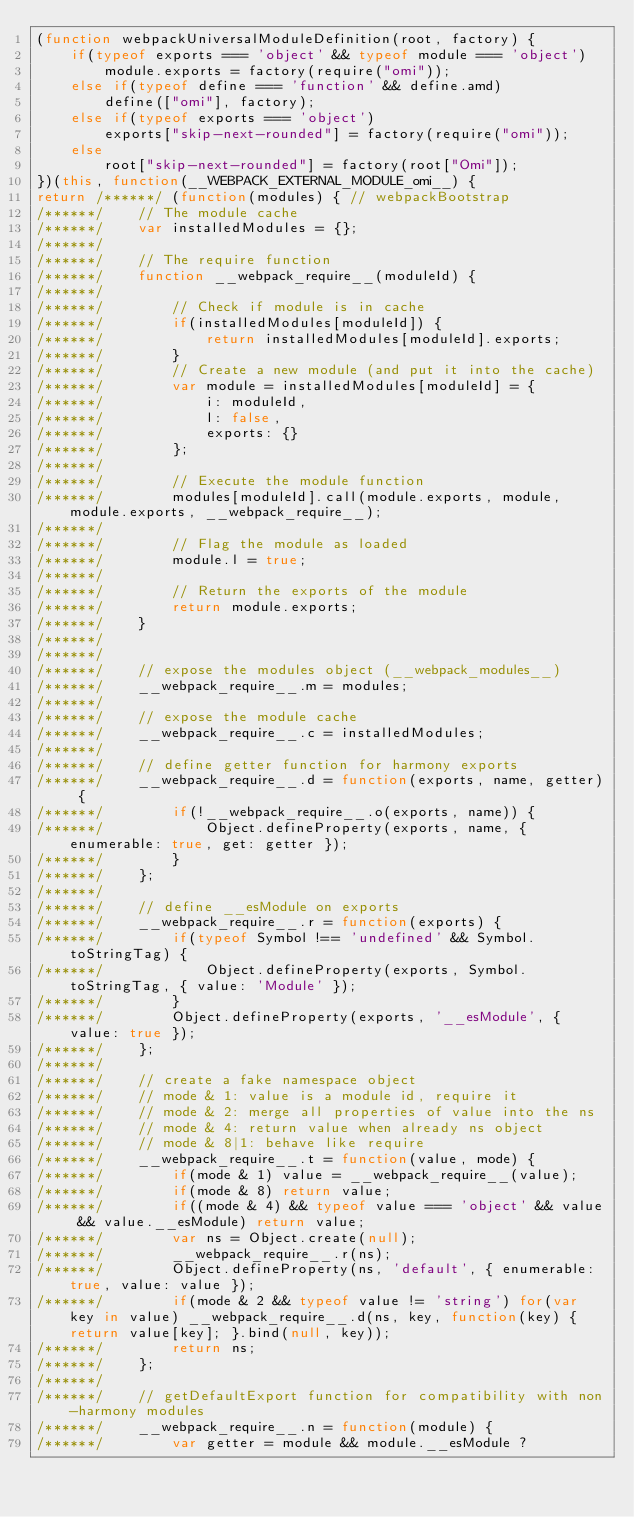<code> <loc_0><loc_0><loc_500><loc_500><_JavaScript_>(function webpackUniversalModuleDefinition(root, factory) {
	if(typeof exports === 'object' && typeof module === 'object')
		module.exports = factory(require("omi"));
	else if(typeof define === 'function' && define.amd)
		define(["omi"], factory);
	else if(typeof exports === 'object')
		exports["skip-next-rounded"] = factory(require("omi"));
	else
		root["skip-next-rounded"] = factory(root["Omi"]);
})(this, function(__WEBPACK_EXTERNAL_MODULE_omi__) {
return /******/ (function(modules) { // webpackBootstrap
/******/ 	// The module cache
/******/ 	var installedModules = {};
/******/
/******/ 	// The require function
/******/ 	function __webpack_require__(moduleId) {
/******/
/******/ 		// Check if module is in cache
/******/ 		if(installedModules[moduleId]) {
/******/ 			return installedModules[moduleId].exports;
/******/ 		}
/******/ 		// Create a new module (and put it into the cache)
/******/ 		var module = installedModules[moduleId] = {
/******/ 			i: moduleId,
/******/ 			l: false,
/******/ 			exports: {}
/******/ 		};
/******/
/******/ 		// Execute the module function
/******/ 		modules[moduleId].call(module.exports, module, module.exports, __webpack_require__);
/******/
/******/ 		// Flag the module as loaded
/******/ 		module.l = true;
/******/
/******/ 		// Return the exports of the module
/******/ 		return module.exports;
/******/ 	}
/******/
/******/
/******/ 	// expose the modules object (__webpack_modules__)
/******/ 	__webpack_require__.m = modules;
/******/
/******/ 	// expose the module cache
/******/ 	__webpack_require__.c = installedModules;
/******/
/******/ 	// define getter function for harmony exports
/******/ 	__webpack_require__.d = function(exports, name, getter) {
/******/ 		if(!__webpack_require__.o(exports, name)) {
/******/ 			Object.defineProperty(exports, name, { enumerable: true, get: getter });
/******/ 		}
/******/ 	};
/******/
/******/ 	// define __esModule on exports
/******/ 	__webpack_require__.r = function(exports) {
/******/ 		if(typeof Symbol !== 'undefined' && Symbol.toStringTag) {
/******/ 			Object.defineProperty(exports, Symbol.toStringTag, { value: 'Module' });
/******/ 		}
/******/ 		Object.defineProperty(exports, '__esModule', { value: true });
/******/ 	};
/******/
/******/ 	// create a fake namespace object
/******/ 	// mode & 1: value is a module id, require it
/******/ 	// mode & 2: merge all properties of value into the ns
/******/ 	// mode & 4: return value when already ns object
/******/ 	// mode & 8|1: behave like require
/******/ 	__webpack_require__.t = function(value, mode) {
/******/ 		if(mode & 1) value = __webpack_require__(value);
/******/ 		if(mode & 8) return value;
/******/ 		if((mode & 4) && typeof value === 'object' && value && value.__esModule) return value;
/******/ 		var ns = Object.create(null);
/******/ 		__webpack_require__.r(ns);
/******/ 		Object.defineProperty(ns, 'default', { enumerable: true, value: value });
/******/ 		if(mode & 2 && typeof value != 'string') for(var key in value) __webpack_require__.d(ns, key, function(key) { return value[key]; }.bind(null, key));
/******/ 		return ns;
/******/ 	};
/******/
/******/ 	// getDefaultExport function for compatibility with non-harmony modules
/******/ 	__webpack_require__.n = function(module) {
/******/ 		var getter = module && module.__esModule ?</code> 